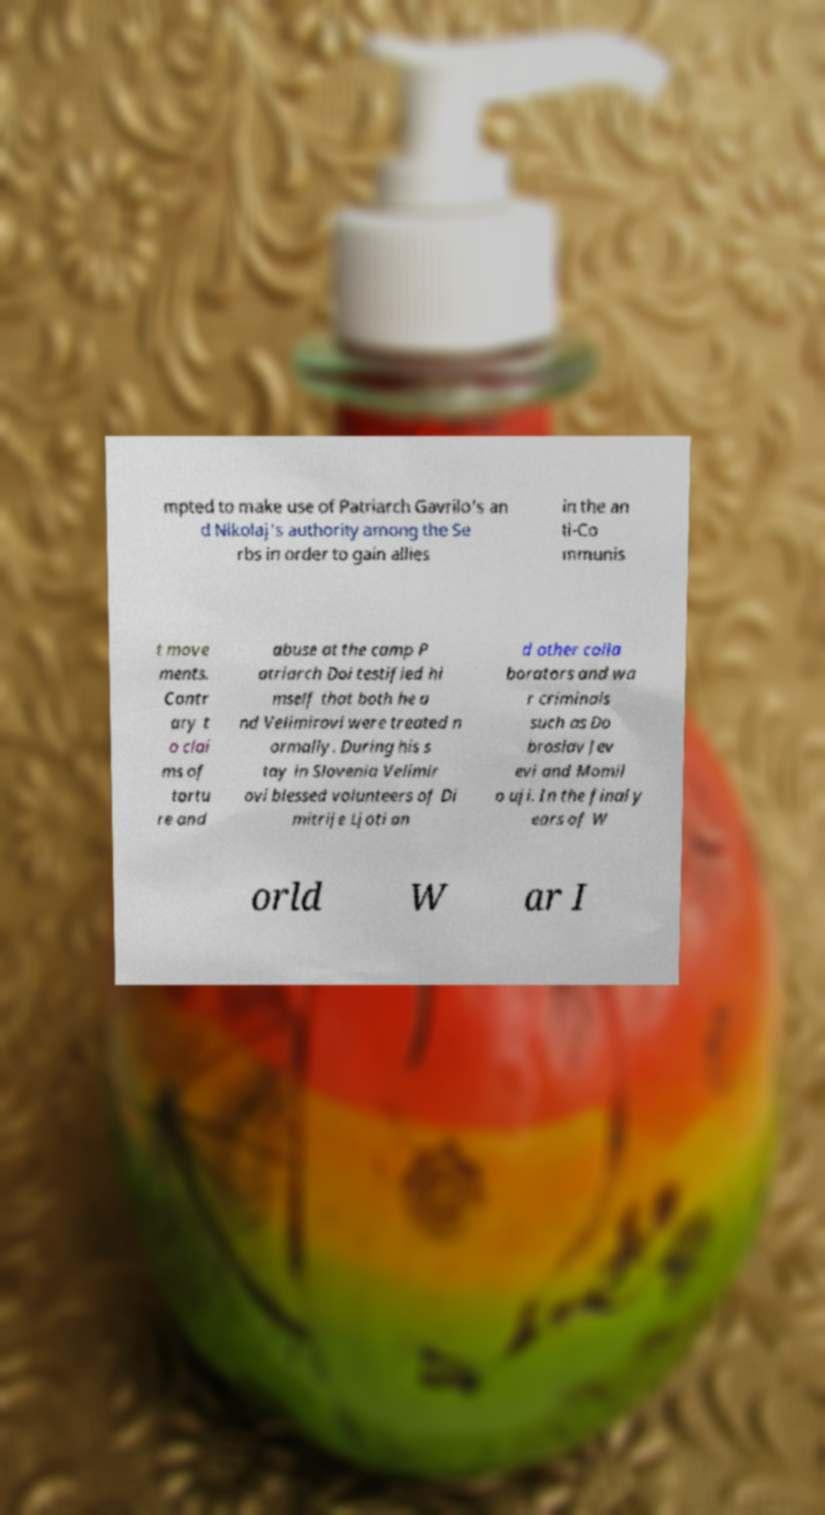Could you extract and type out the text from this image? mpted to make use of Patriarch Gavrilo's an d Nikolaj's authority among the Se rbs in order to gain allies in the an ti-Co mmunis t move ments. Contr ary t o clai ms of tortu re and abuse at the camp P atriarch Doi testified hi mself that both he a nd Velimirovi were treated n ormally. During his s tay in Slovenia Velimir ovi blessed volunteers of Di mitrije Ljoti an d other colla borators and wa r criminals such as Do broslav Jev evi and Momil o uji. In the final y ears of W orld W ar I 